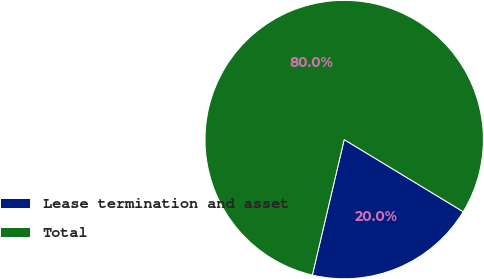Convert chart. <chart><loc_0><loc_0><loc_500><loc_500><pie_chart><fcel>Lease termination and asset<fcel>Total<nl><fcel>20.0%<fcel>80.0%<nl></chart> 